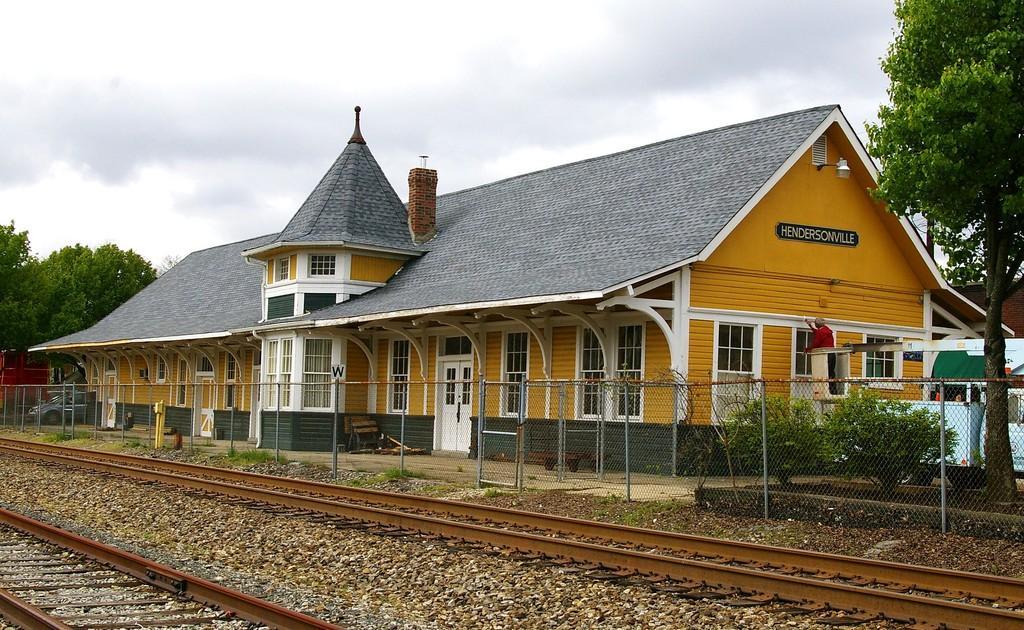Please provide a concise description of this image. In the middle of the image we can see a house and a person is standing and a mesh are there. On the right side of the image we can see a truck and some plants are there. On the left side of the image we can see a car and trees are present. At the top of the image clouds are present in the sky. At the bottom of the image we can see railway track, grass and ground are present. 